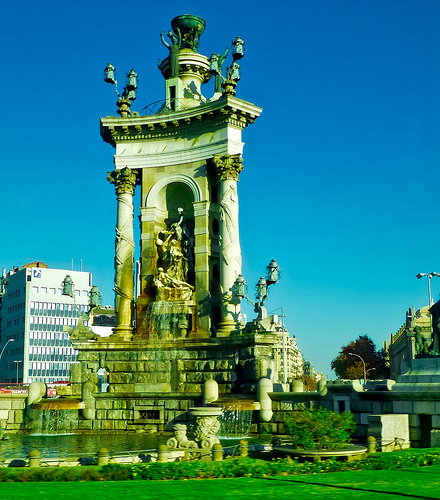<image>
Can you confirm if the monument is in front of the sky? Yes. The monument is positioned in front of the sky, appearing closer to the camera viewpoint. 